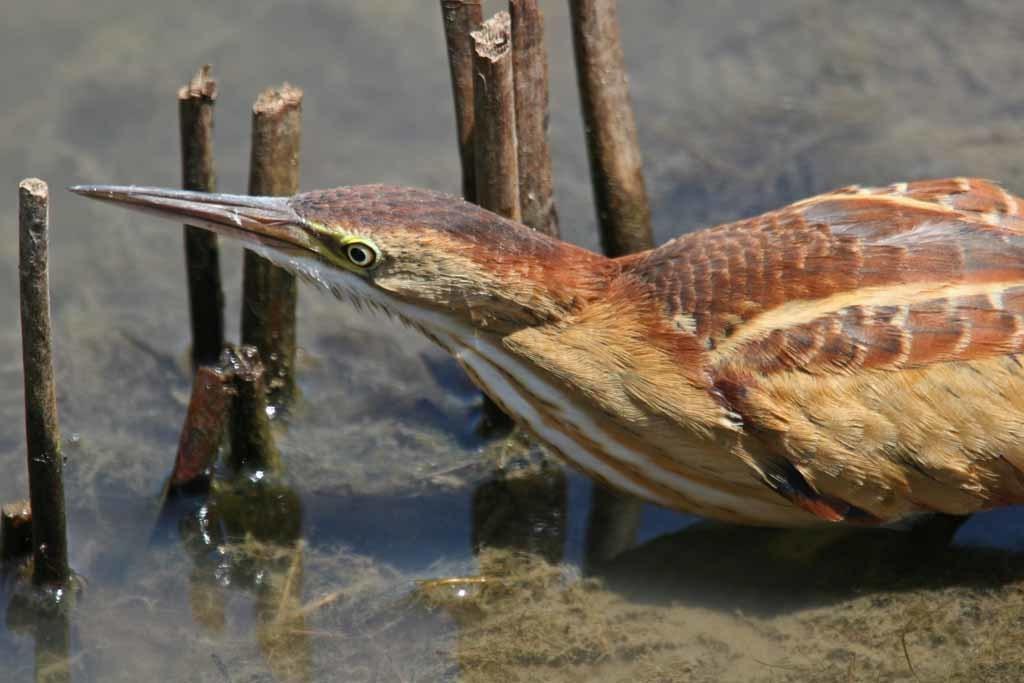Can you describe this image briefly? In this image on the right side, I can see a bird. I can see the sticks. In the background, I can see the water. 